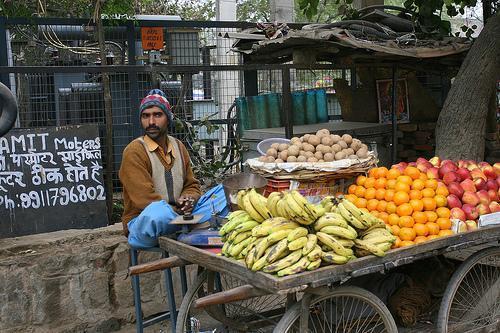How many people are pictured?
Give a very brief answer. 1. 